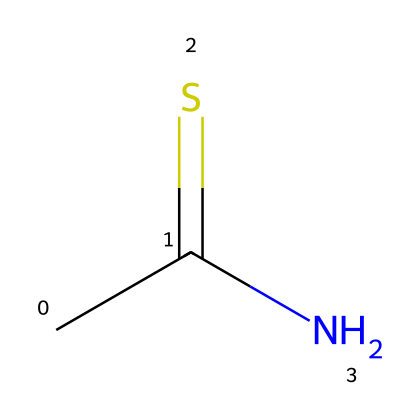What is the molecular formula of thioacetamide? From the SMILES representation CC(=S)N, we can identify the atoms present: 2 Carbon (C), 1 Sulfur (S), and 1 Nitrogen (N) along with 5 Hydrogens. This leads us to the molecular formula C2H5NS.
Answer: C2H5NS How many carbon atoms are in thioacetamide? Examining the SMILES representation, CC indicates there are two Carbon atoms in the structure.
Answer: 2 What type of bonding is present in thioacetamide? The SMILES representation shows that CC is connected by a single bond, C(=S) has a double bond, and CN is a single bond. Therefore, it contains both single and double bonds.
Answer: single and double Which element has the highest electronegativity in thioacetamide? Among the elements listed in thioacetamide (C, H, N, S), Nitrogen is the most electronegative element based on periodic trends, marked as having the highest electronegativity.
Answer: Nitrogen Is thioacetamide a polar or nonpolar compound? Looking at the functional groups and the presence of Nitrogen and Sulfur, the molecule has polar bonds. Since the molecular geometry is asymmetrical, it is a polar compound overall.
Answer: polar What functional group is present in thioacetamide? The SMILES indicates the presence of a thioamide group (C(=S)N), where the carbon is double bonded to sulfur and single bonded to nitrogen. This makes it a thioamide.
Answer: thioamide What is the role of thioacetamide in electronic component manufacturing? Thioacetamide is commonly used as a precursor in the synthesis of materials or processes needed for electronic components, particularly for its properties that facilitate the production of conductive materials.
Answer: precursor 